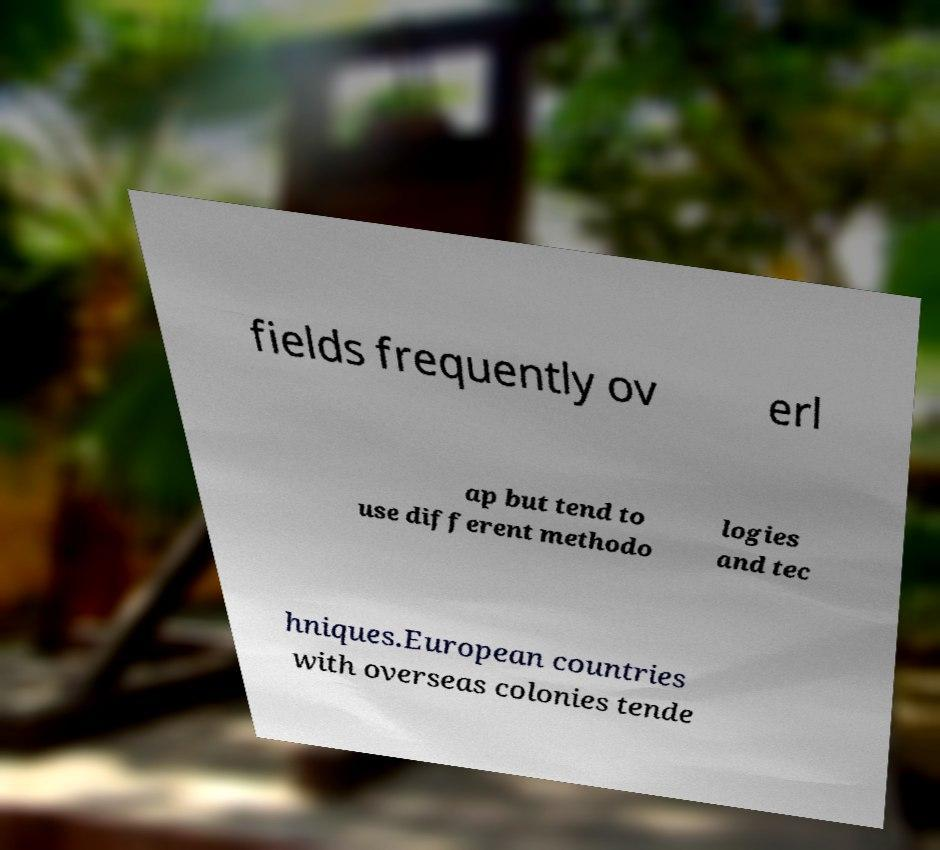Please read and relay the text visible in this image. What does it say? fields frequently ov erl ap but tend to use different methodo logies and tec hniques.European countries with overseas colonies tende 